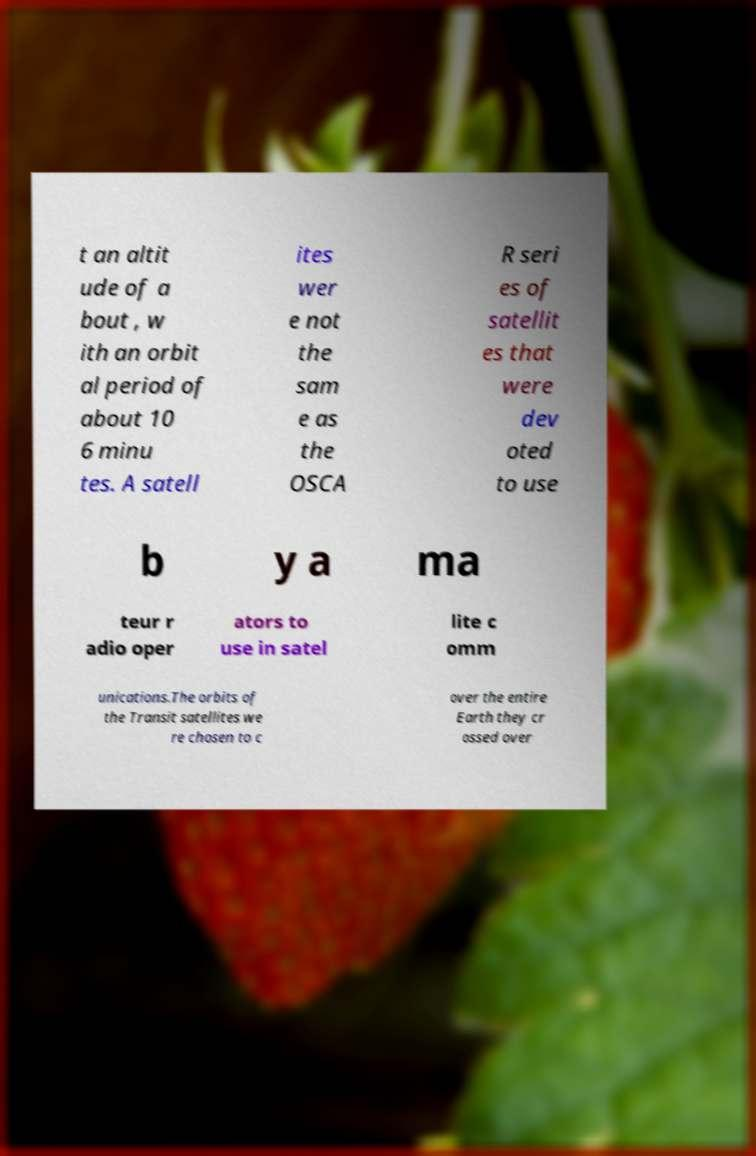Please read and relay the text visible in this image. What does it say? t an altit ude of a bout , w ith an orbit al period of about 10 6 minu tes. A satell ites wer e not the sam e as the OSCA R seri es of satellit es that were dev oted to use b y a ma teur r adio oper ators to use in satel lite c omm unications.The orbits of the Transit satellites we re chosen to c over the entire Earth they cr ossed over 